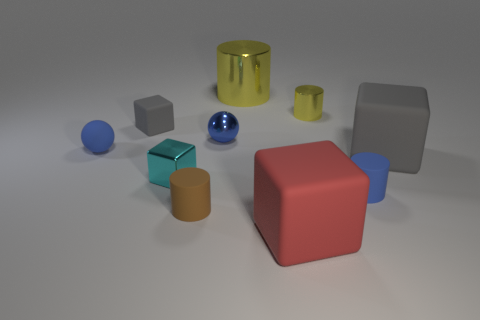Subtract all green balls. How many yellow cylinders are left? 2 Subtract 2 blocks. How many blocks are left? 2 Subtract all red blocks. How many blocks are left? 3 Subtract all small brown rubber cylinders. How many cylinders are left? 3 Subtract all purple balls. Subtract all green cubes. How many balls are left? 2 Subtract all cylinders. How many objects are left? 6 Add 4 big gray matte things. How many big gray matte things exist? 5 Subtract 0 purple balls. How many objects are left? 10 Subtract all tiny red shiny spheres. Subtract all large matte objects. How many objects are left? 8 Add 1 small cyan shiny blocks. How many small cyan shiny blocks are left? 2 